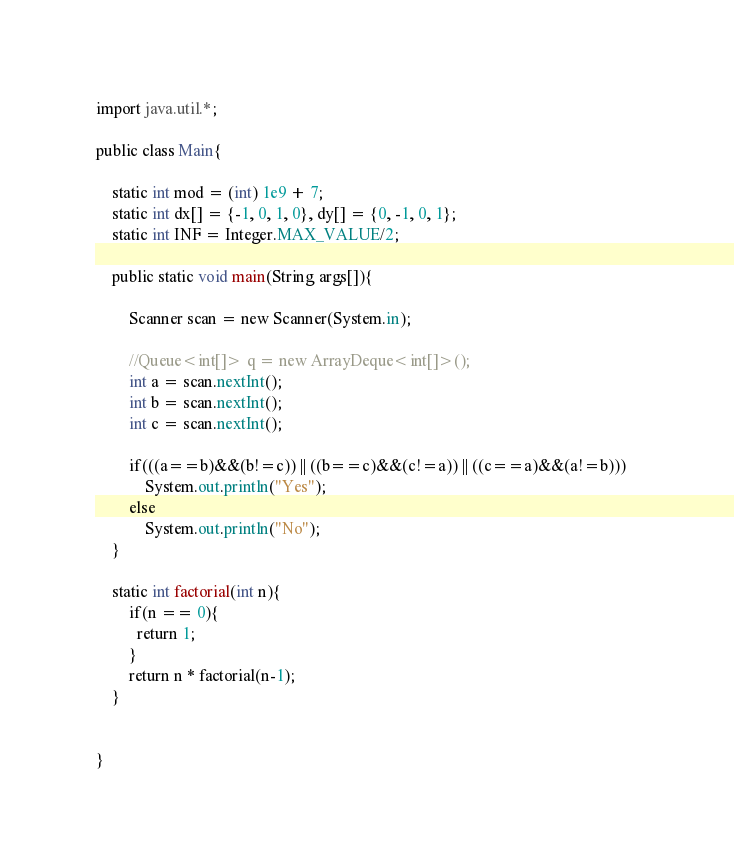Convert code to text. <code><loc_0><loc_0><loc_500><loc_500><_Java_>import java.util.*;

public class Main{

    static int mod = (int) 1e9 + 7;
    static int dx[] = {-1, 0, 1, 0}, dy[] = {0, -1, 0, 1};
    static int INF = Integer.MAX_VALUE/2;

    public static void main(String args[]){

        Scanner scan = new Scanner(System.in);

        //Queue<int[]> q = new ArrayDeque<int[]>();
        int a = scan.nextInt();
        int b = scan.nextInt();
        int c = scan.nextInt();

        if(((a==b)&&(b!=c)) || ((b==c)&&(c!=a)) || ((c==a)&&(a!=b)))   
            System.out.println("Yes");
        else
            System.out.println("No");
    }

    static int factorial(int n){
        if(n == 0){
          return 1;
        }
        return n * factorial(n-1);
    }


}</code> 